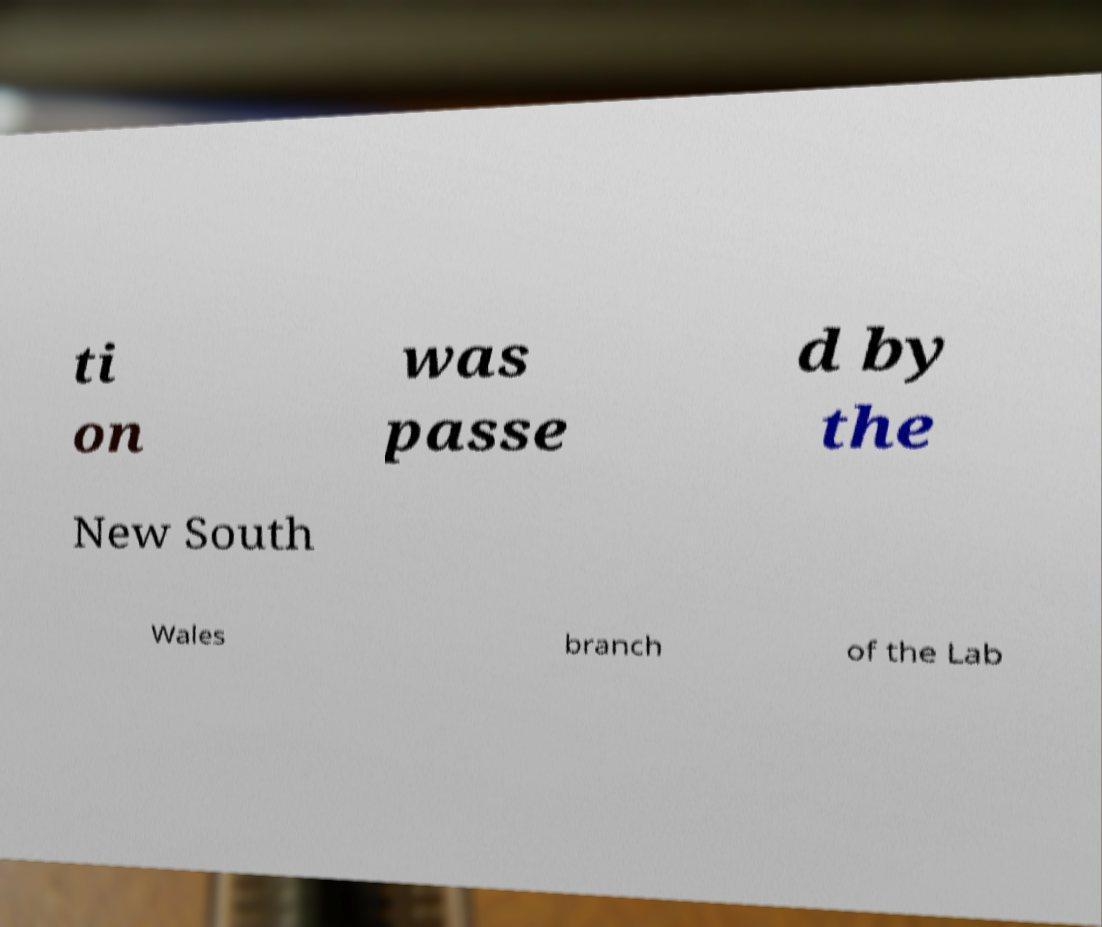There's text embedded in this image that I need extracted. Can you transcribe it verbatim? ti on was passe d by the New South Wales branch of the Lab 